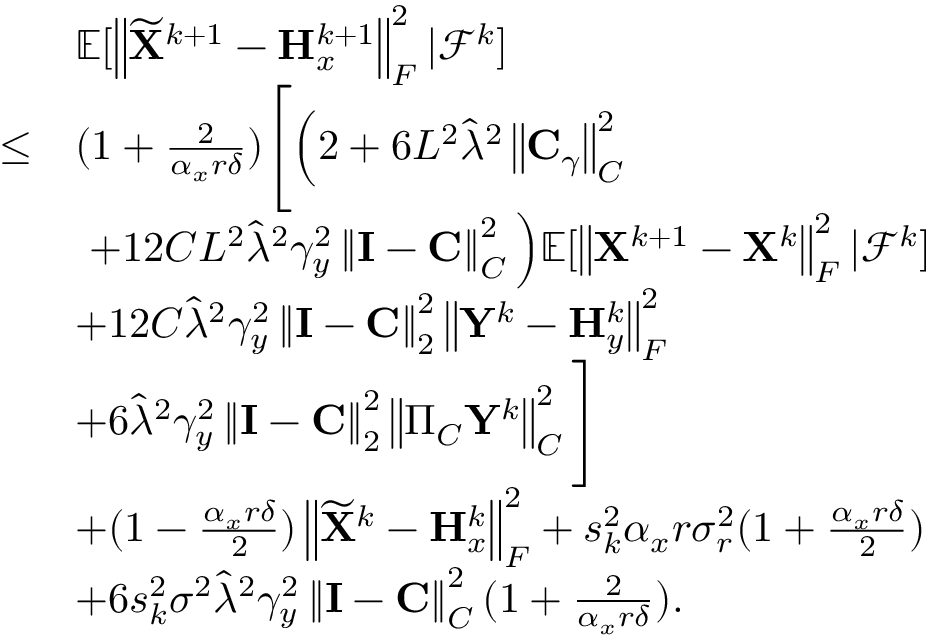<formula> <loc_0><loc_0><loc_500><loc_500>\begin{array} { r l } & { { \mathbb { E } } [ \left \| \widetilde { X } ^ { k + 1 } - { H } _ { x } ^ { k + 1 } \right \| _ { F } ^ { 2 } | { \mathcal { F } } ^ { k } ] } \\ { \leq } & { ( 1 + \frac { 2 } { \alpha _ { x } r \delta } ) \left [ \left ( 2 + 6 L ^ { 2 } \widehat { \lambda } ^ { 2 } \left \| { C } _ { \gamma } \right \| _ { C } ^ { 2 } } \\ & { + 1 2 C L ^ { 2 } \widehat { \lambda } ^ { 2 } \gamma _ { y } ^ { 2 } \left \| { I } - { C } \right \| _ { C } ^ { 2 } \right ) { \mathbb { E } } [ \left \| { X } ^ { k + 1 } - { X } ^ { k } \right \| _ { F } ^ { 2 } | { \mathcal { F } } ^ { k } ] } \\ & { + 1 2 C \widehat { \lambda } ^ { 2 } \gamma _ { y } ^ { 2 } \left \| { I } - { C } \right \| _ { 2 } ^ { 2 } \left \| { Y } ^ { k } - { H } _ { y } ^ { k } \right \| _ { F } ^ { 2 } } \\ & { + 6 \widehat { \lambda } ^ { 2 } \gamma _ { y } ^ { 2 } \left \| { I } - { C } \right \| _ { 2 } ^ { 2 } \left \| \Pi _ { C } { Y } ^ { k } \right \| _ { C } ^ { 2 } \right ] } \\ & { + ( 1 - \frac { \alpha _ { x } r \delta } { 2 } ) \left \| \widetilde { X } ^ { k } - { H } _ { x } ^ { k } \right \| _ { F } ^ { 2 } + s _ { k } ^ { 2 } \alpha _ { x } r \sigma _ { r } ^ { 2 } ( 1 + \frac { \alpha _ { x } r \delta } { 2 } ) } \\ & { + 6 s _ { k } ^ { 2 } \sigma ^ { 2 } \widehat { \lambda } ^ { 2 } \gamma _ { y } ^ { 2 } \left \| { I } - { C } \right \| _ { C } ^ { 2 } ( 1 + \frac { 2 } { \alpha _ { x } r \delta } ) . } \end{array}</formula> 